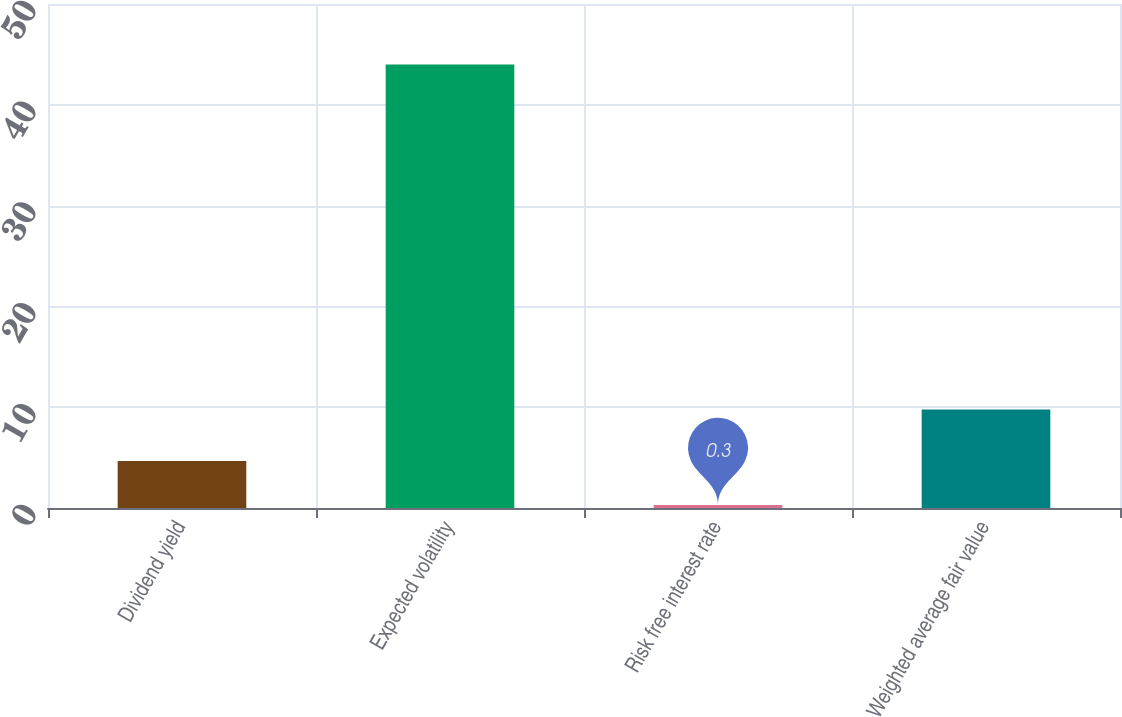Convert chart to OTSL. <chart><loc_0><loc_0><loc_500><loc_500><bar_chart><fcel>Dividend yield<fcel>Expected volatility<fcel>Risk free interest rate<fcel>Weighted average fair value<nl><fcel>4.67<fcel>44<fcel>0.3<fcel>9.76<nl></chart> 